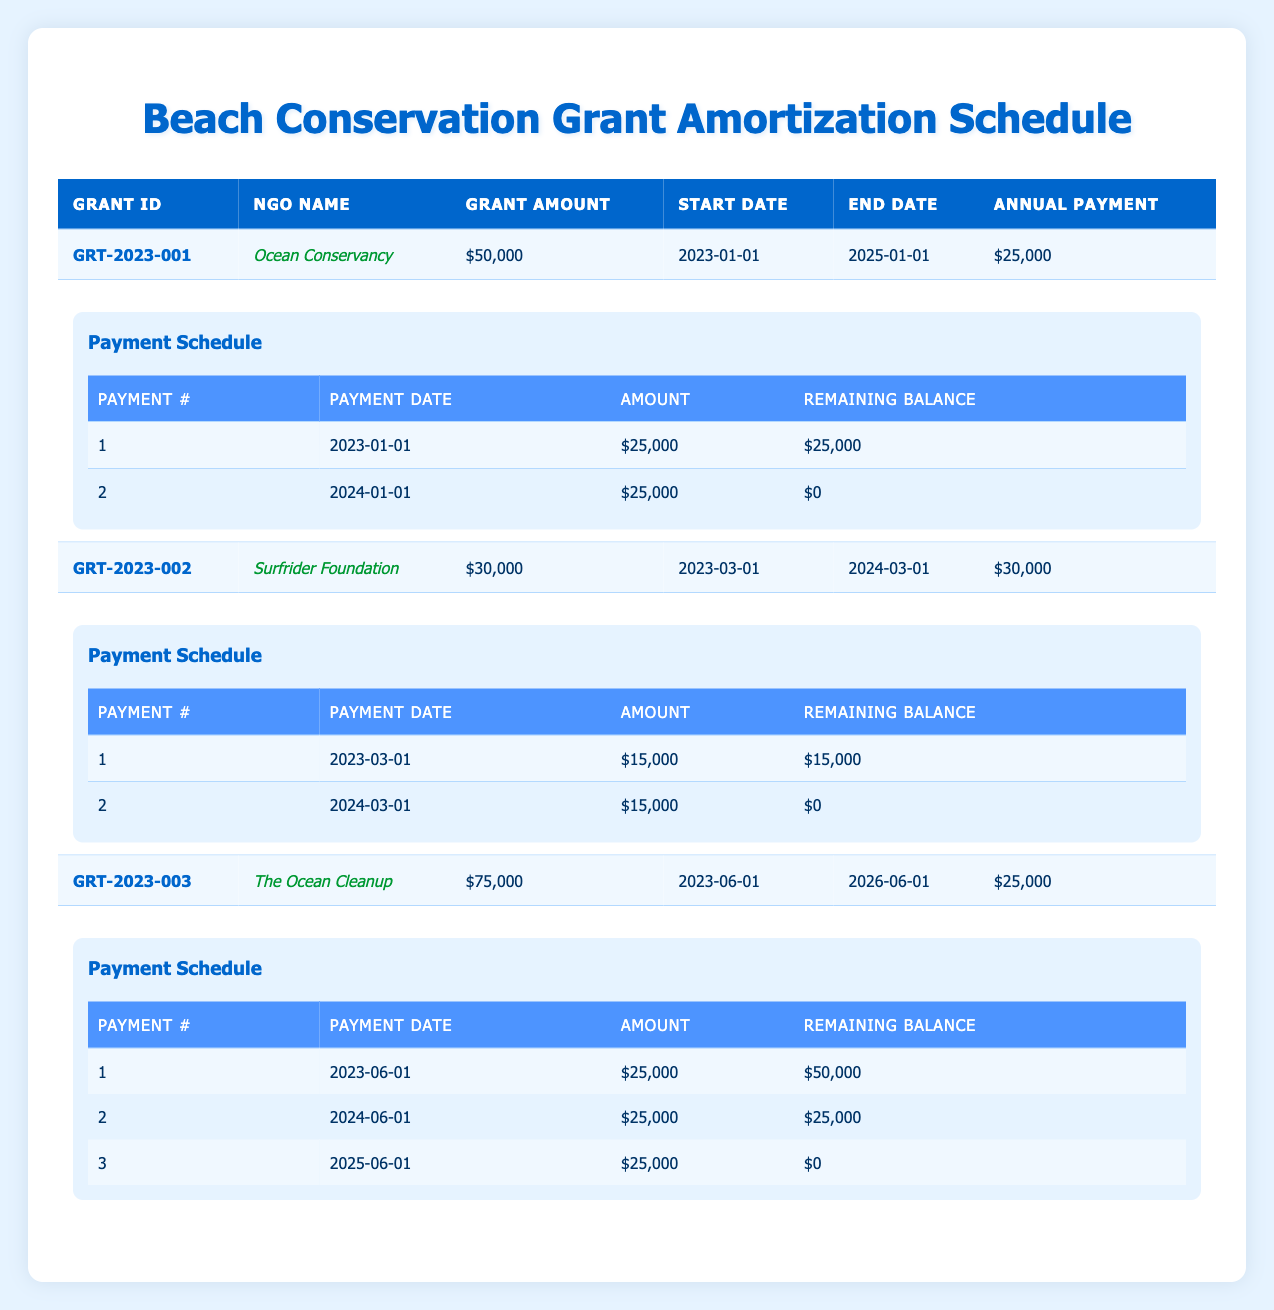What is the total grant amount awarded to Ocean Conservancy? The grant amount listed for Ocean Conservancy under Grant ID GRT-2023-001 is $50,000.
Answer: $50,000 How many payments are scheduled for Surfrider Foundation? Surfrider Foundation, under Grant ID GRT-2023-002, has a payment schedule that lists 2 payments.
Answer: 2 What is the remaining balance after the first payment for The Ocean Cleanup? The first payment listed for The Ocean Cleanup is $25,000, and the remaining balance after that payment is $50,000.
Answer: $50,000 Did Ocean Conservancy receive more funding than Surfrider Foundation? Ocean Conservancy received $50,000 and Surfrider Foundation received $30,000, so Ocean Conservancy did receive more funding.
Answer: Yes What is the average annual payment across all NGOs? The annual payments are $25,000 for Ocean Conservancy, $30,000 for Surfrider Foundation, and $25,000 for The Ocean Cleanup. Summing them gives $25,000 + $30,000 + $25,000 = $80,000. There are 3 NGOs, so the average is $80,000 / 3 = $26,666.67.
Answer: $26,666.67 What is the payment date for the second installment of the grant awarded to Ocean Conservancy? The payment schedule for Ocean Conservancy shows that the second payment is scheduled for January 1, 2024.
Answer: January 1, 2024 How much total funding is scheduled to be paid to The Ocean Cleanup over the entire grant period? The total amount awarded to The Ocean Cleanup is $75,000, and it will be paid across 3 installments of $25,000 each, confirming that the total funding remains $75,000.
Answer: $75,000 Is the remaining balance after the first payment for Surfrider Foundation zero? After the first payment of $15,000 for Surfrider Foundation, the remaining balance is $15,000, which means it is not zero.
Answer: No Which NGO has the latest grant end date? The grant end dates are January 1, 2025 for Ocean Conservancy, March 1, 2024 for Surfrider Foundation, and June 1, 2026 for The Ocean Cleanup. The latest date is therefore June 1, 2026.
Answer: The Ocean Cleanup 